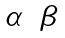Convert formula to latex. <formula><loc_0><loc_0><loc_500><loc_500>\begin{matrix} \alpha & \beta \end{matrix}</formula> 